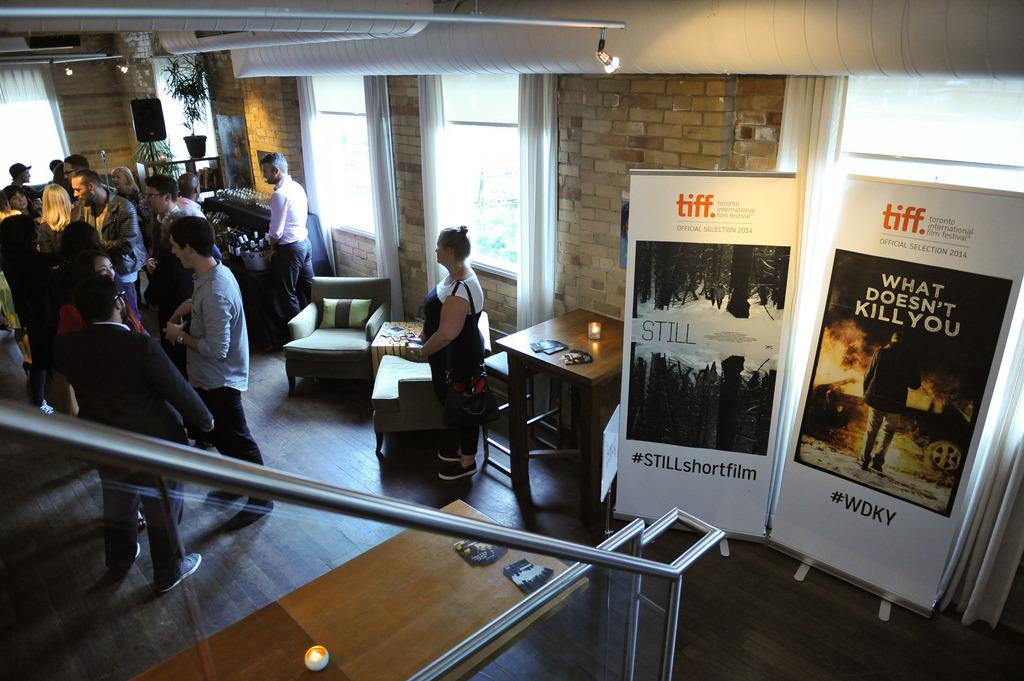What can be seen in the image? There are people standing in the image. Where are the people standing? The people are standing on the floor. What other objects are present in the image? There are tables, chairs, and posters in the image. What is the condition of the sky in the image? The background of the image is cloudy. What type of tooth is being advertised on the poster in the image? There is no tooth or advertisement present on the posters in the image. Can you tell me how many grapes are on the table in the image? There are no grapes visible on the tables in the image. 